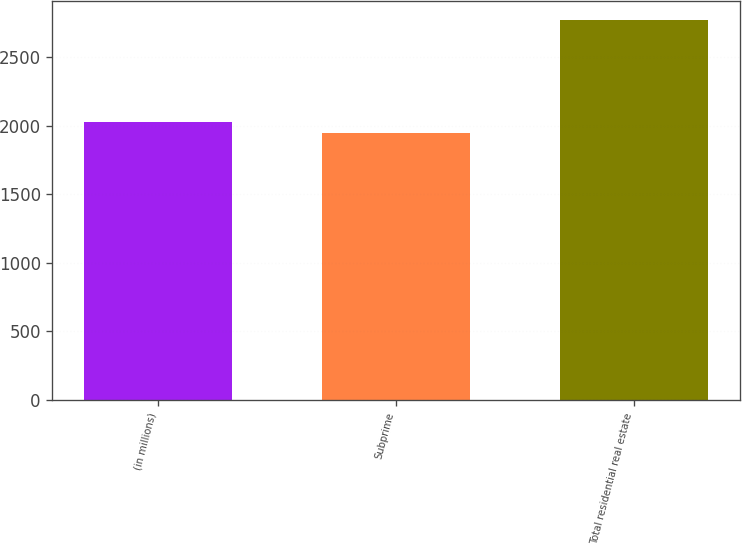Convert chart to OTSL. <chart><loc_0><loc_0><loc_500><loc_500><bar_chart><fcel>(in millions)<fcel>Subprime<fcel>Total residential real estate<nl><fcel>2030.5<fcel>1948<fcel>2773<nl></chart> 